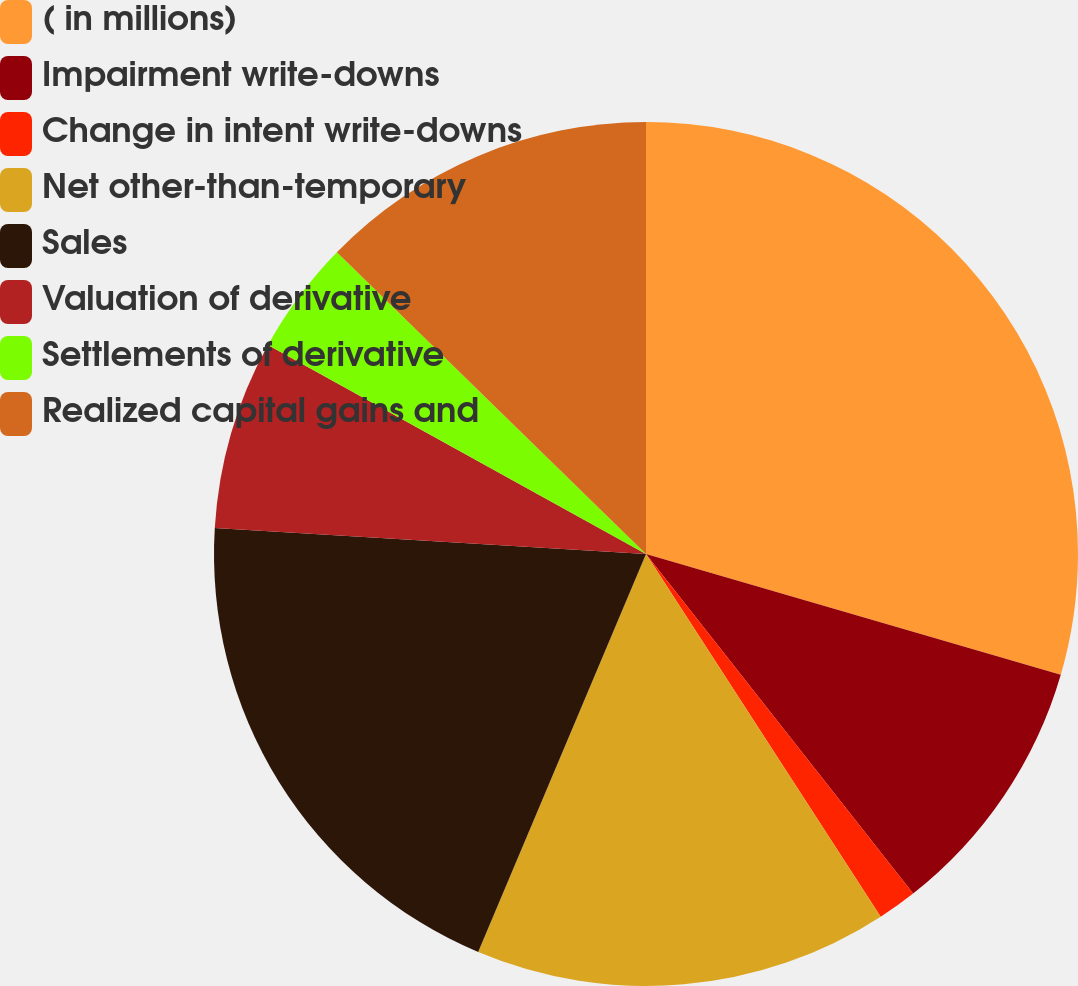Convert chart to OTSL. <chart><loc_0><loc_0><loc_500><loc_500><pie_chart><fcel>( in millions)<fcel>Impairment write-downs<fcel>Change in intent write-downs<fcel>Net other-than-temporary<fcel>Sales<fcel>Valuation of derivative<fcel>Settlements of derivative<fcel>Realized capital gains and<nl><fcel>29.51%<fcel>9.88%<fcel>1.47%<fcel>15.49%<fcel>19.61%<fcel>7.08%<fcel>4.27%<fcel>12.69%<nl></chart> 